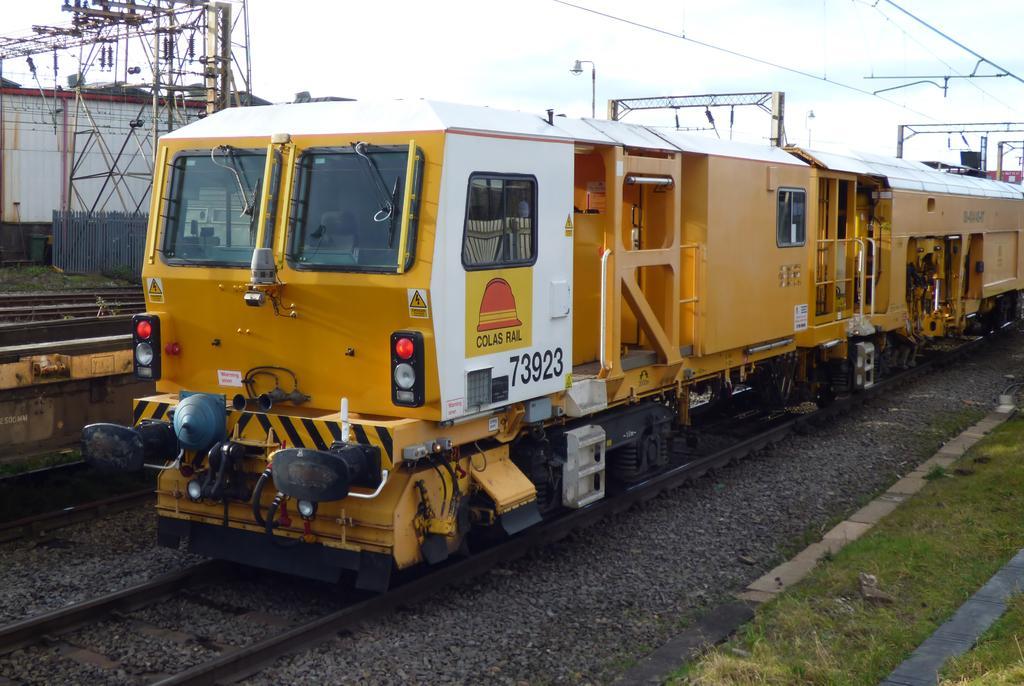Could you give a brief overview of what you see in this image? In this picture we can see grass and a train on the tracks, in the background we can find few poles, cables and fence. 